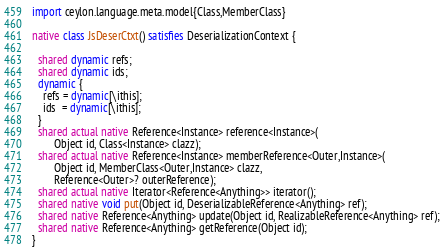Convert code to text. <code><loc_0><loc_0><loc_500><loc_500><_Ceylon_>import ceylon.language.meta.model{Class,MemberClass}

native class JsDeserCtxt() satisfies DeserializationContext {

  shared dynamic refs;
  shared dynamic ids;
  dynamic {
    refs = dynamic[\ithis];
    ids  = dynamic[\ithis];
  }
  shared actual native Reference<Instance> reference<Instance>(
        Object id, Class<Instance> clazz);
  shared actual native Reference<Instance> memberReference<Outer,Instance>(
        Object id, MemberClass<Outer,Instance> clazz,
        Reference<Outer>? outerReference);
  shared actual native Iterator<Reference<Anything>> iterator();
  shared native void put(Object id, DeserializableReference<Anything> ref);
  shared native Reference<Anything> update(Object id, RealizableReference<Anything> ref);
  shared native Reference<Anything> getReference(Object id);
}
</code> 